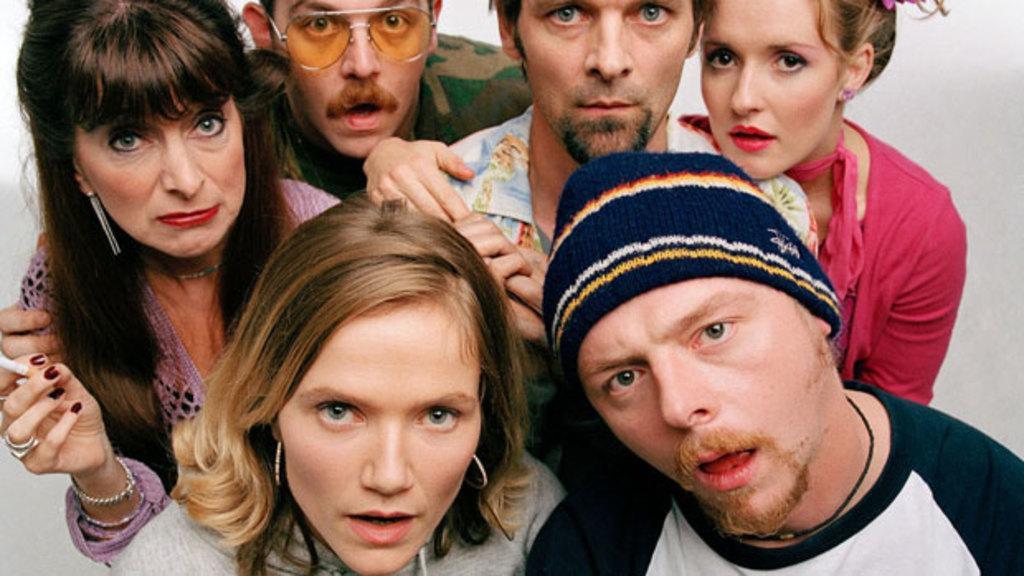Could you give a brief overview of what you see in this image? In this image we can see few people. There is a white background. 